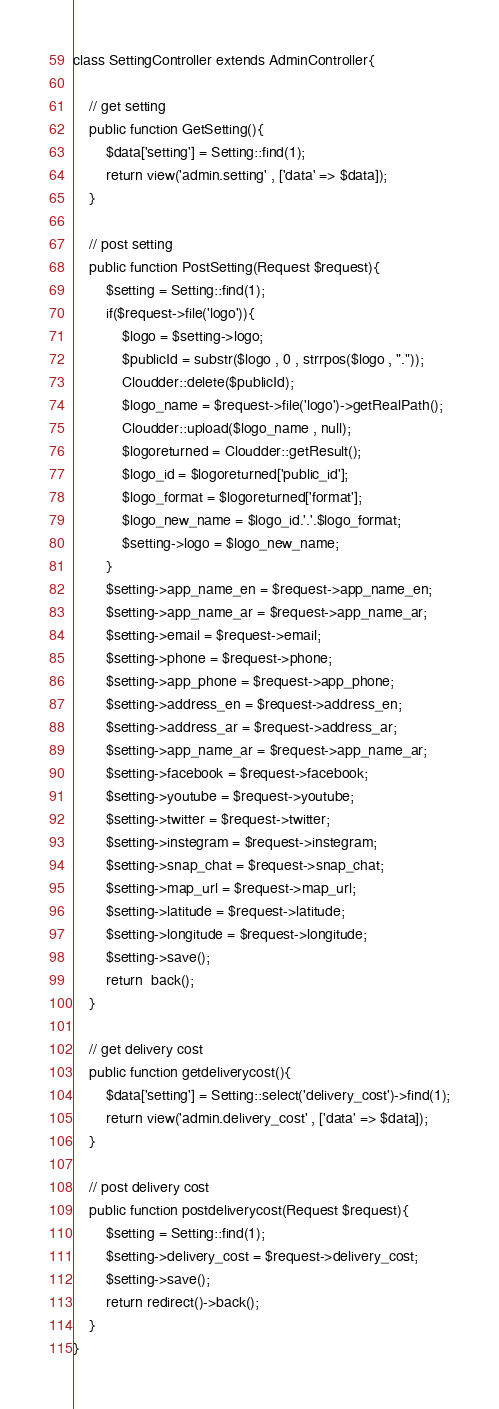Convert code to text. <code><loc_0><loc_0><loc_500><loc_500><_PHP_>class SettingController extends AdminController{
    
    // get setting
    public function GetSetting(){
        $data['setting'] = Setting::find(1);
        return view('admin.setting' , ['data' => $data]);
    }

    // post setting
    public function PostSetting(Request $request){
        $setting = Setting::find(1);
        if($request->file('logo')){
            $logo = $setting->logo;
            $publicId = substr($logo , 0 , strrpos($logo , "."));
            Cloudder::delete($publicId);
            $logo_name = $request->file('logo')->getRealPath();
            Cloudder::upload($logo_name , null);
            $logoreturned = Cloudder::getResult();
            $logo_id = $logoreturned['public_id'];
            $logo_format = $logoreturned['format'];
            $logo_new_name = $logo_id.'.'.$logo_format;
            $setting->logo = $logo_new_name;    
        }
        $setting->app_name_en = $request->app_name_en;
        $setting->app_name_ar = $request->app_name_ar;
        $setting->email = $request->email;
        $setting->phone = $request->phone;
        $setting->app_phone = $request->app_phone;
        $setting->address_en = $request->address_en;
        $setting->address_ar = $request->address_ar;
        $setting->app_name_ar = $request->app_name_ar;
        $setting->facebook = $request->facebook;
        $setting->youtube = $request->youtube;
        $setting->twitter = $request->twitter;
        $setting->instegram = $request->instegram;
        $setting->snap_chat = $request->snap_chat;
        $setting->map_url = $request->map_url;
        $setting->latitude = $request->latitude;
        $setting->longitude = $request->longitude;
        $setting->save();
        return  back();
    }

    // get delivery cost
    public function getdeliverycost(){
        $data['setting'] = Setting::select('delivery_cost')->find(1);
        return view('admin.delivery_cost' , ['data' => $data]);
    }

    // post delivery cost
    public function postdeliverycost(Request $request){
        $setting = Setting::find(1);
        $setting->delivery_cost = $request->delivery_cost;
        $setting->save();
        return redirect()->back();
    }    
}</code> 